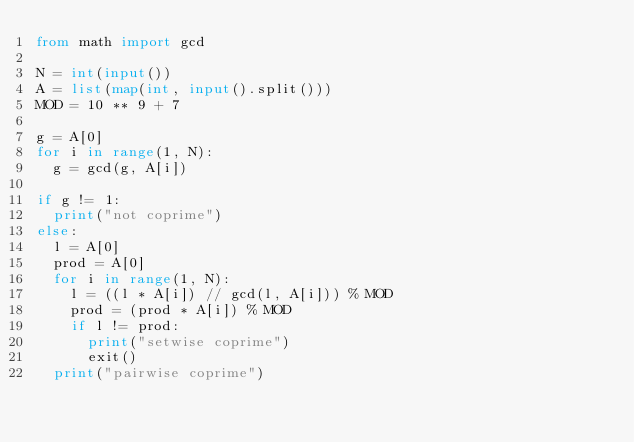<code> <loc_0><loc_0><loc_500><loc_500><_Python_>from math import gcd

N = int(input())
A = list(map(int, input().split()))
MOD = 10 ** 9 + 7

g = A[0]
for i in range(1, N):
	g = gcd(g, A[i])
	
if g != 1:
	print("not coprime")
else:
	l = A[0]
	prod = A[0]
	for i in range(1, N):
		l = ((l * A[i]) // gcd(l, A[i])) % MOD
		prod = (prod * A[i]) % MOD
		if l != prod:
			print("setwise coprime")
			exit()
	print("pairwise coprime")</code> 